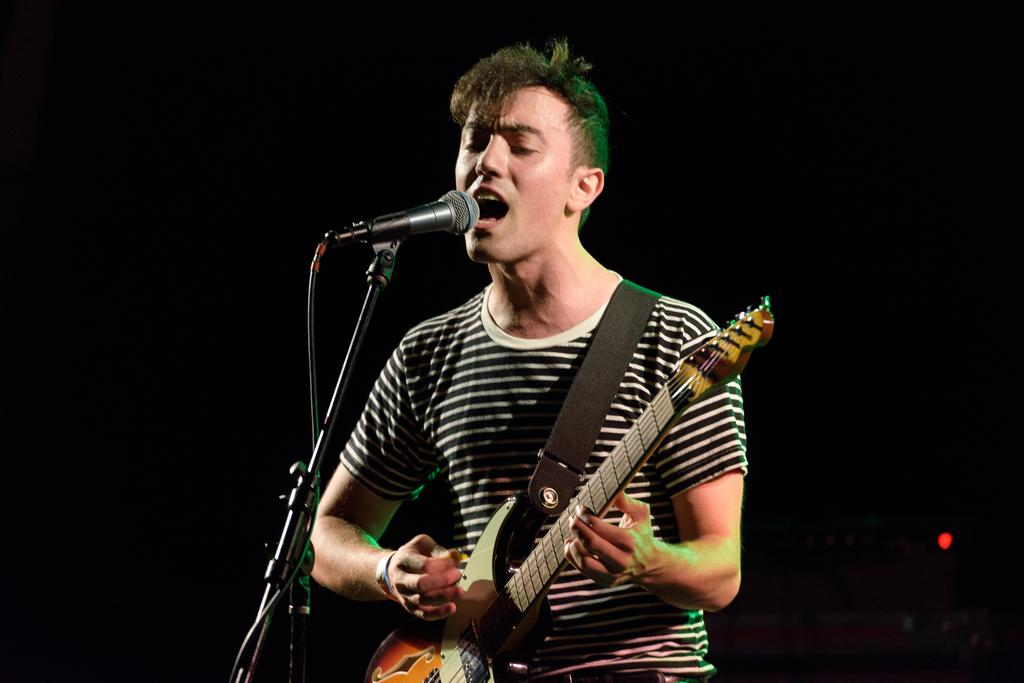What is the main subject of the image? The main subject of the image is a man. What is the man wearing in the image? The man is wearing a T-shirt in the image. What is the man doing in the image? The man is standing, playing a guitar, and singing a song in the image. What object is present in the image that is related to the man's singing? There is a microphone in the image, which is attached to a microphone stand. Can you see any beggars in the image? No, there are no beggars present in the image. Is the man in the image flying an airplane? No, the man is not flying an airplane in the image; he is playing a guitar and singing. 